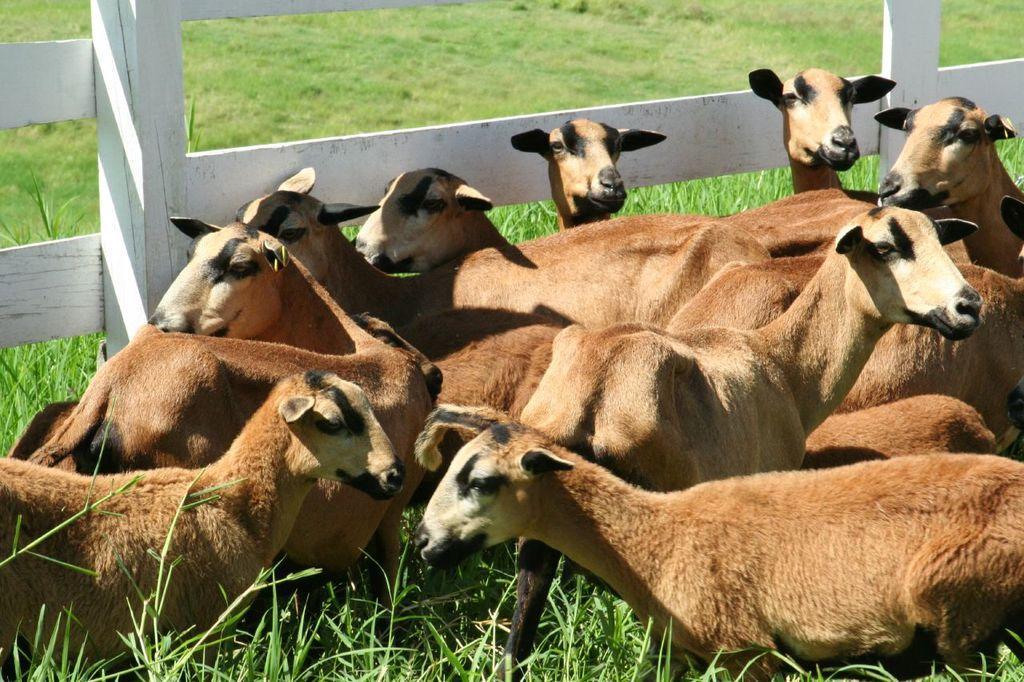Please provide a concise description of this image. In this image in the front there are animals. In the center there is a wooden fence and in the background there is grass on the ground. 